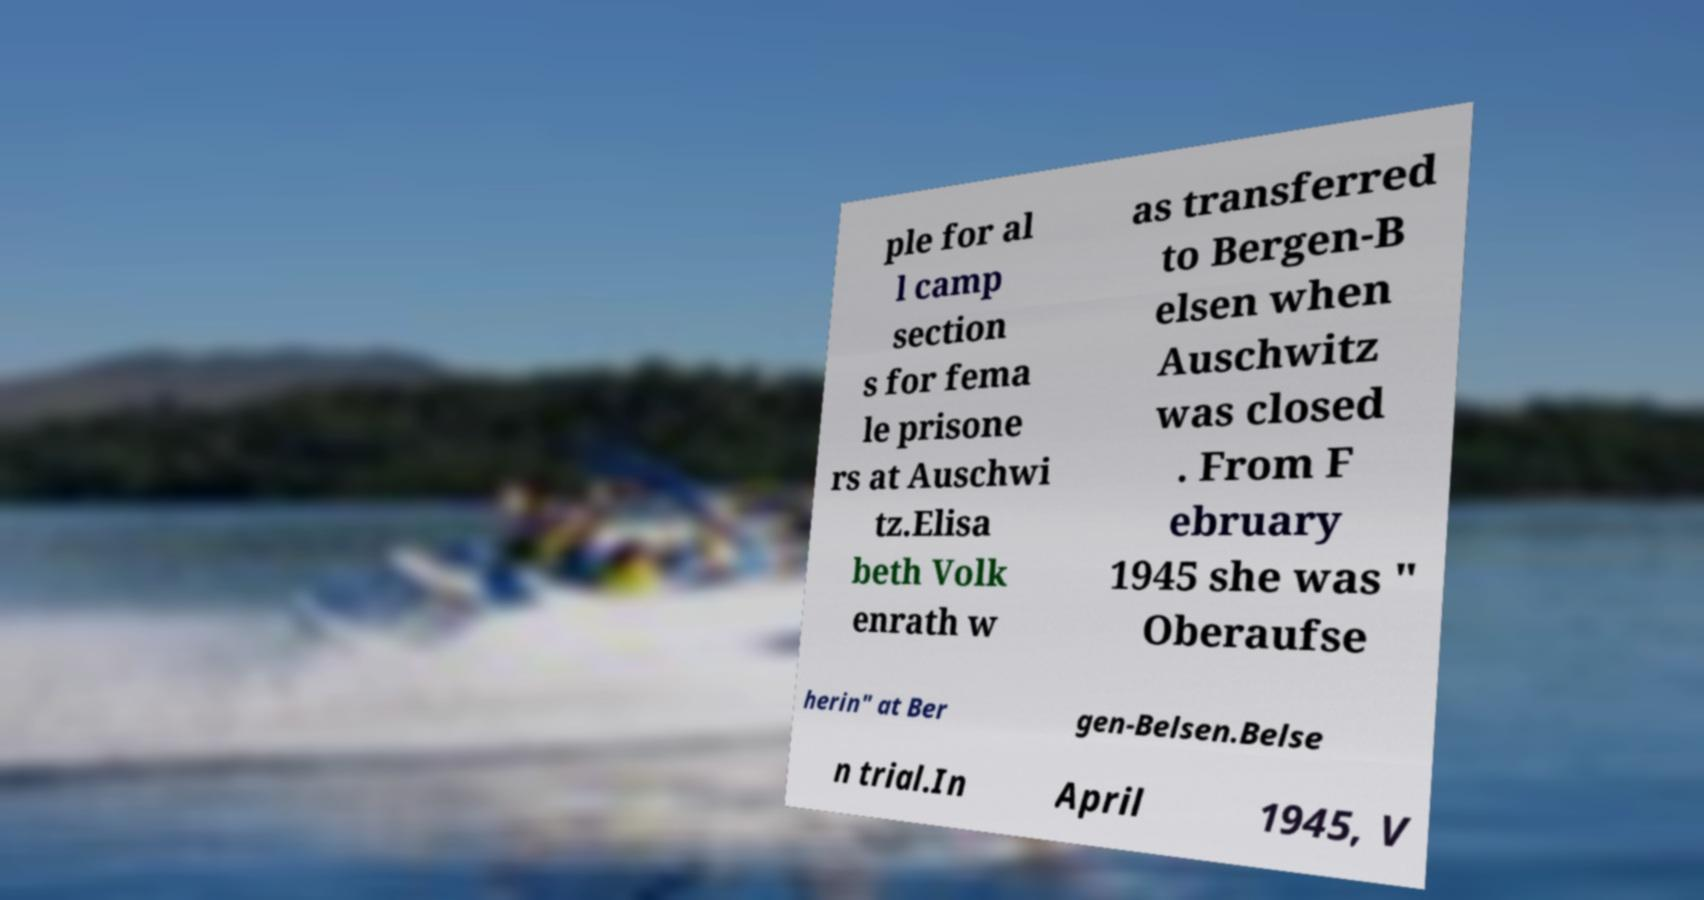There's text embedded in this image that I need extracted. Can you transcribe it verbatim? ple for al l camp section s for fema le prisone rs at Auschwi tz.Elisa beth Volk enrath w as transferred to Bergen-B elsen when Auschwitz was closed . From F ebruary 1945 she was " Oberaufse herin" at Ber gen-Belsen.Belse n trial.In April 1945, V 